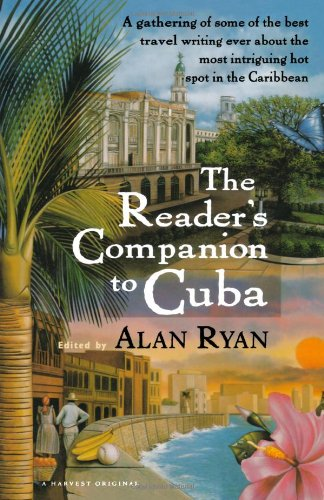What is the genre of this book? Given the title and thematic elements depicted on the cover, the book falls within the travel genre. 